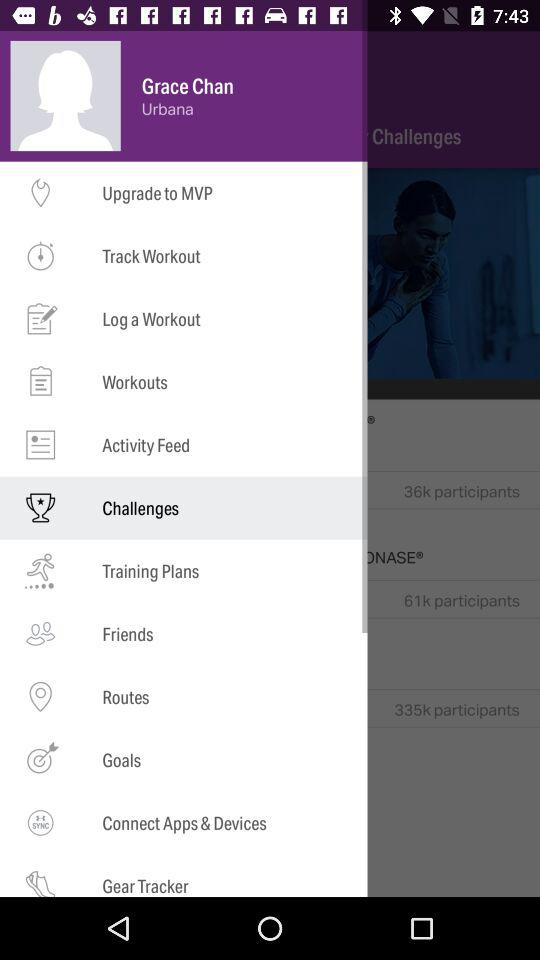What is the name of the user? The name of the user is Grace Chan. 